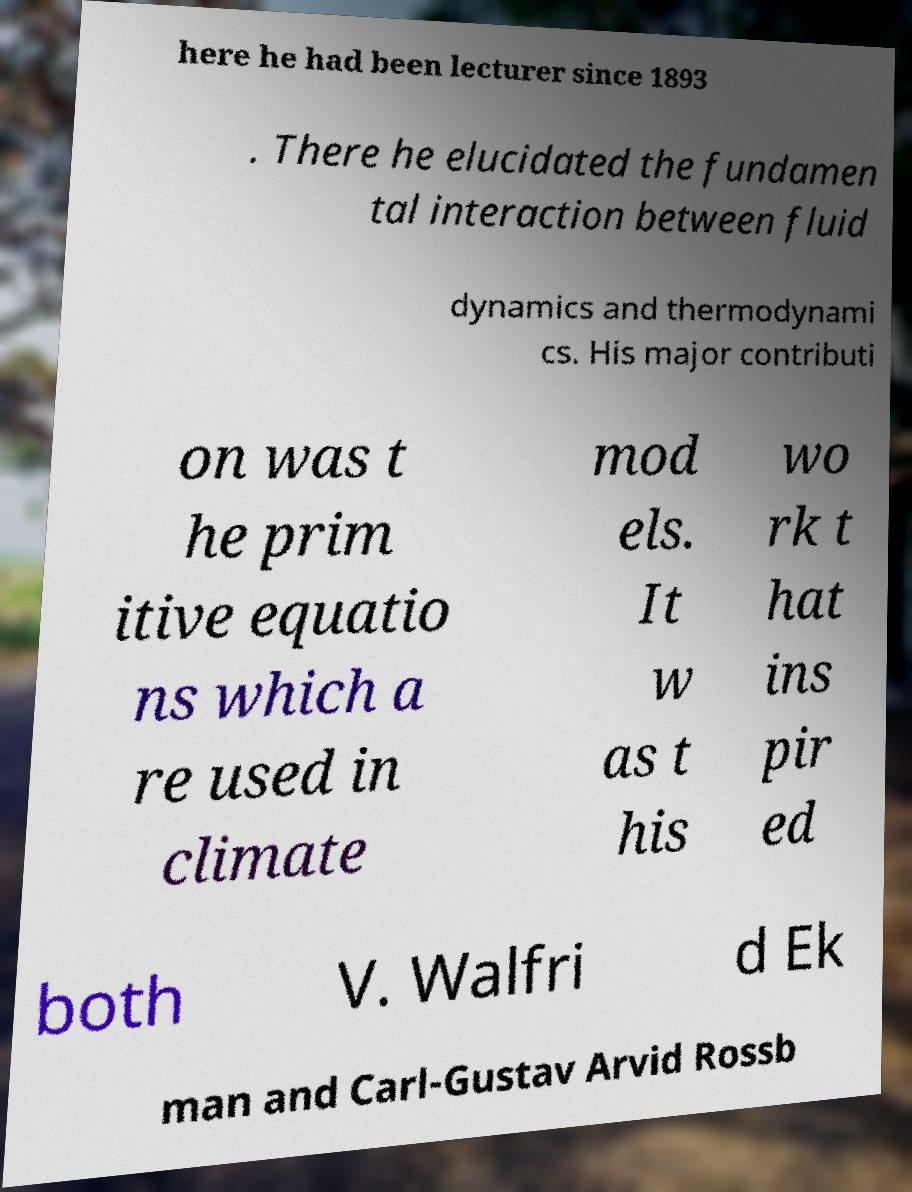Can you accurately transcribe the text from the provided image for me? here he had been lecturer since 1893 . There he elucidated the fundamen tal interaction between fluid dynamics and thermodynami cs. His major contributi on was t he prim itive equatio ns which a re used in climate mod els. It w as t his wo rk t hat ins pir ed both V. Walfri d Ek man and Carl-Gustav Arvid Rossb 